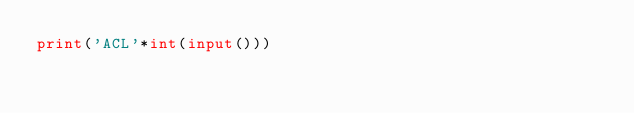<code> <loc_0><loc_0><loc_500><loc_500><_Python_>print('ACL'*int(input()))</code> 